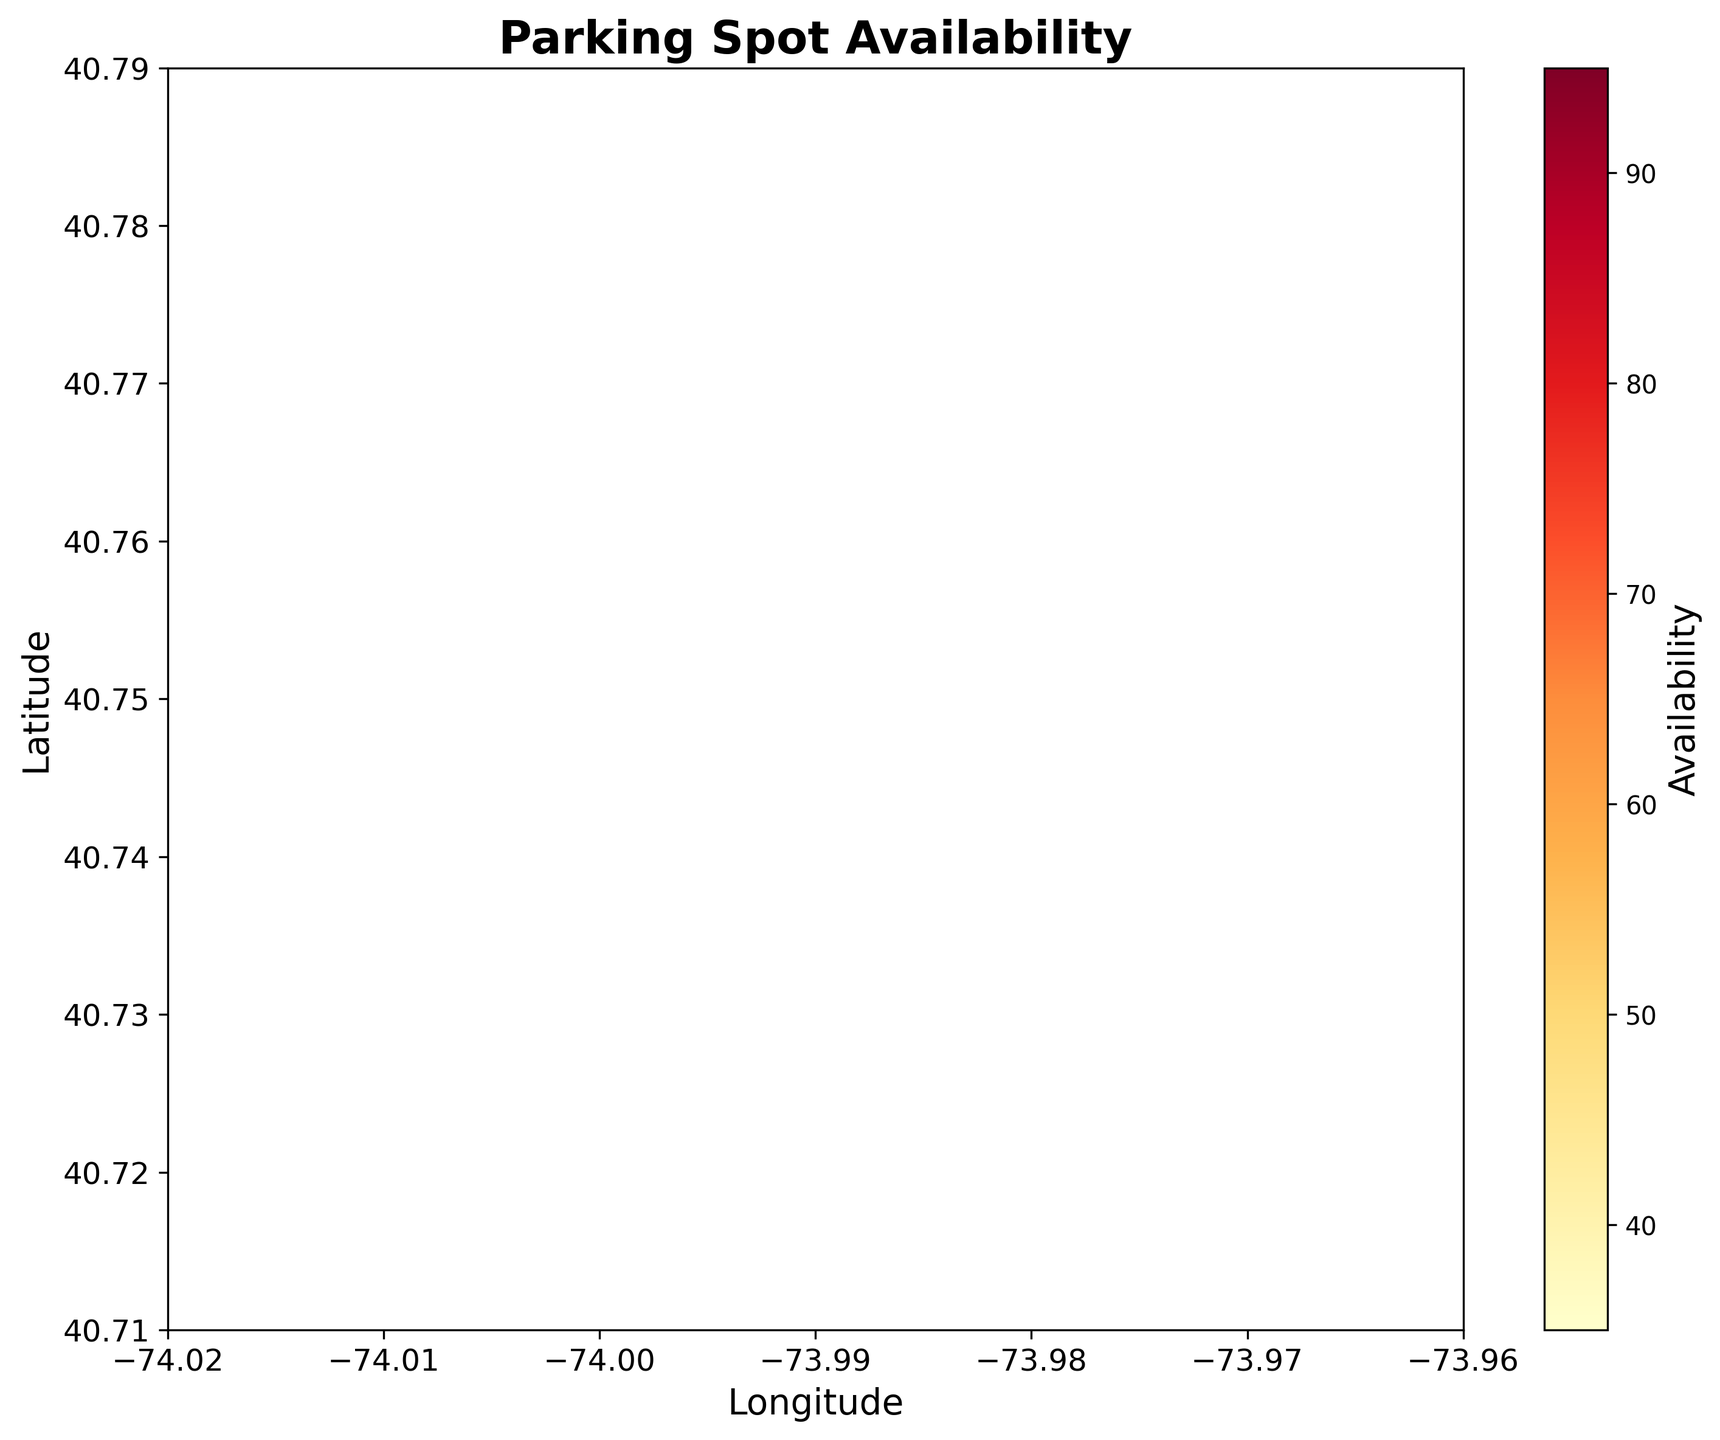What is the title of the plot? The title is the text displayed at the top of the figure. Titles usually describe the main topic or purpose of the plot. Here, the title is "Parking Spot Availability" as indicated at the top of the plot.
Answer: Parking Spot Availability What are the labels of the x and y axes? The x and y axes labels are typically displayed along the respective axes of the plot. Here, the x-axis label is "Longitude" and the y-axis label is "Latitude," as indicated along the bottom and left sides of the figure respectively.
Answer: Longitude and Latitude What is the color representing high parking availability? In the color map used, the colors represent different levels of parking availability. The brighter or more intense colors usually represent higher values. In this plot, the color yellow (YlOr) corresponds to high parking availability, as shown in the color bar.
Answer: Yellow What is the color representing low parking availability? The color map used in the plot assigns darker shades to lower values of parking availability. In this plot, the color red (Rd) represents low parking availability, as indicated by the darkest shades in the color bar.
Answer: Red How many parking spots clusters have a very high availability? To identify clusters with very high availability, we look for areas in the plot with the brightest color (yellow). There are two such clusters: one near longitude -74.01 latitude 40.72, and another near longitude -74.00 latitude 40.72.
Answer: Two Which region has the highest concentration of parking spots with high availability? We identify this by looking at regions with the most intensely colored hexes. The region around longitude -74.01 and latitude 40.72 has the hexes colored yellow, indicating the highest concentration.
Answer: Longitude -74.01 and Latitude 40.72 Are there more areas with low or high parking availability? By estimating the proportion of hexes in different colors, we observe that more hexes are in shades of orange-red than in yellow. This indicates more areas with low parking availability compared to high.
Answer: More areas with low availability What area has the highest parking spot availability? We look at the color bar and the color of hexes to determine the highest availability. The area around longitude -74.01 and latitude 40.72 appears the brightest (yellow), indicating the highest availability.
Answer: Near Longitude -74.01, Latitude 40.72 Does the plot show any data points with zero parking availability? To determine this, we look for the darkest shades in the color map (dark red). No hexes are completely dark red, which indicates no area with zero parking availability.
Answer: No Which longitude range has most of the parking spots clustered? By examining the density and brightness of the hexes horizontally, we observe that most parking spots are clustered between longitudes -74.01 and -73.98.
Answer: -74.01 to -73.98 